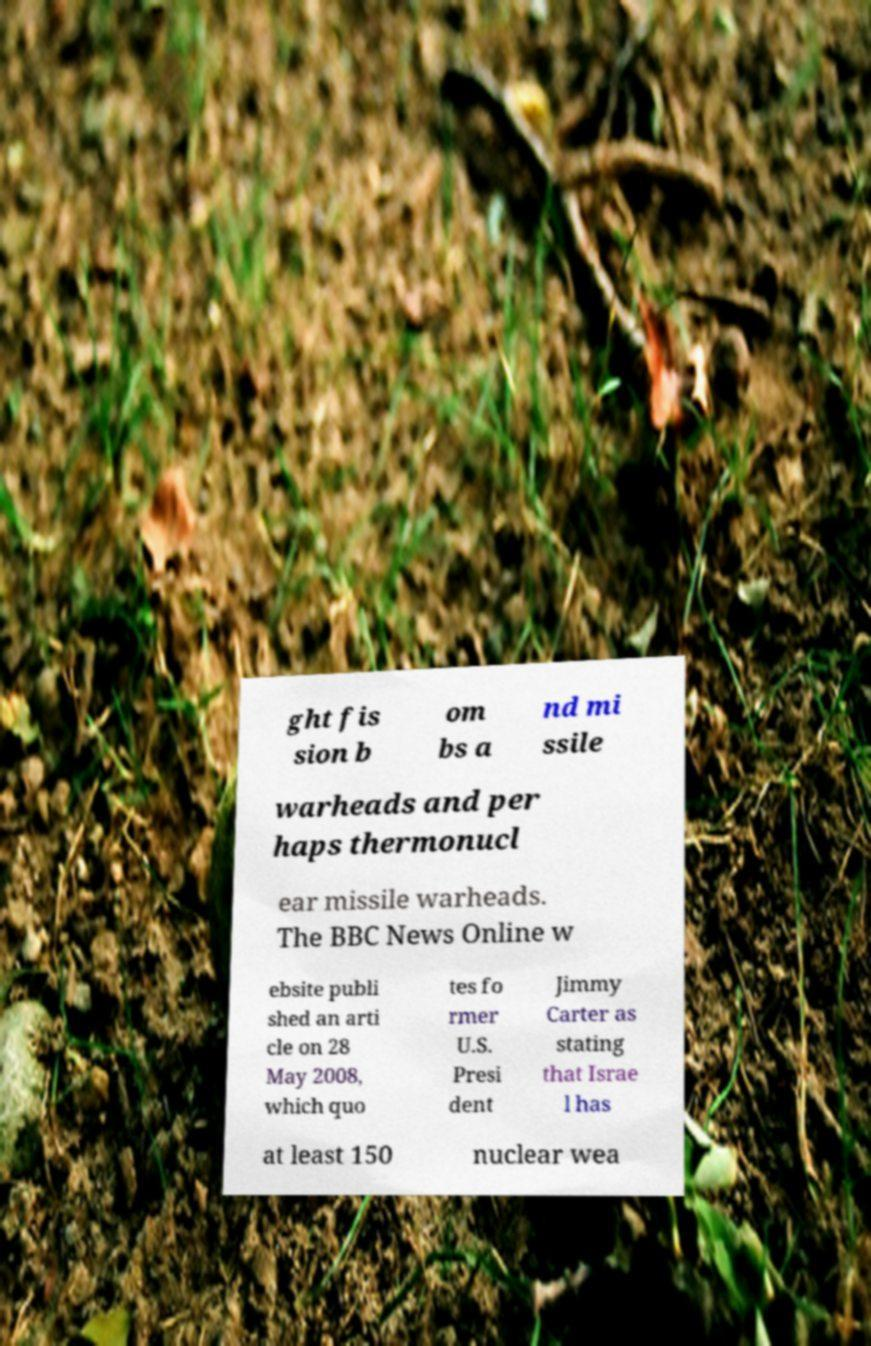Could you assist in decoding the text presented in this image and type it out clearly? ght fis sion b om bs a nd mi ssile warheads and per haps thermonucl ear missile warheads. The BBC News Online w ebsite publi shed an arti cle on 28 May 2008, which quo tes fo rmer U.S. Presi dent Jimmy Carter as stating that Israe l has at least 150 nuclear wea 